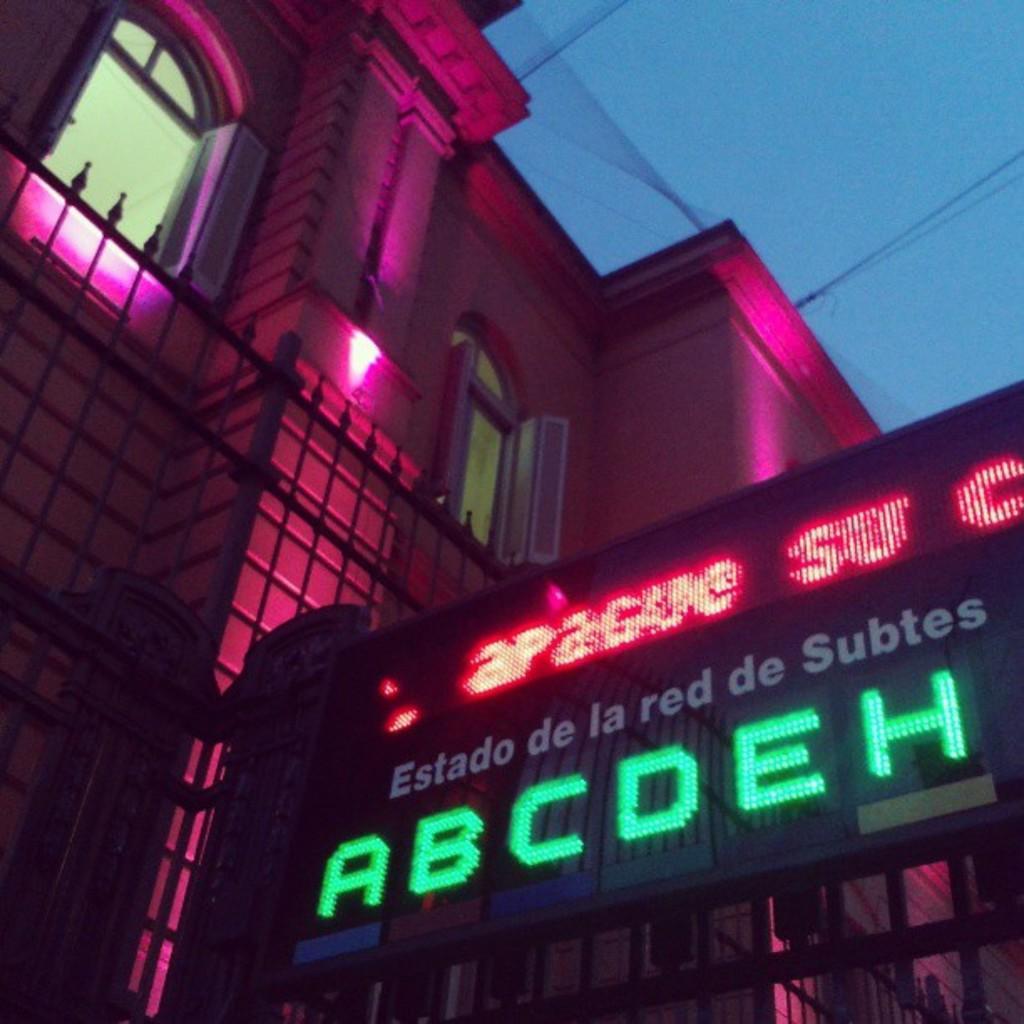In one or two sentences, can you explain what this image depicts? In the picture I can see the building and glass windows. I can see the metal grill fence on the left side. I can see the electric wires on the top right side. I can see an LCD screen on the right side. 